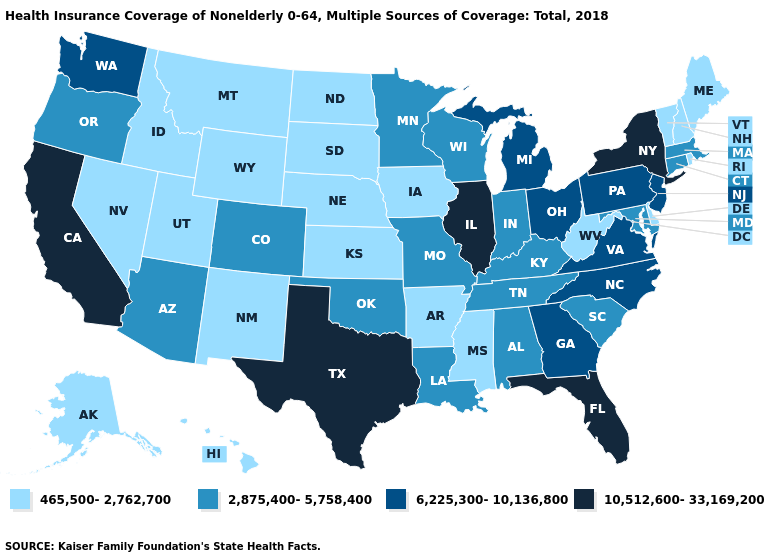What is the value of Oregon?
Concise answer only. 2,875,400-5,758,400. How many symbols are there in the legend?
Give a very brief answer. 4. Name the states that have a value in the range 465,500-2,762,700?
Concise answer only. Alaska, Arkansas, Delaware, Hawaii, Idaho, Iowa, Kansas, Maine, Mississippi, Montana, Nebraska, Nevada, New Hampshire, New Mexico, North Dakota, Rhode Island, South Dakota, Utah, Vermont, West Virginia, Wyoming. Which states have the lowest value in the USA?
Be succinct. Alaska, Arkansas, Delaware, Hawaii, Idaho, Iowa, Kansas, Maine, Mississippi, Montana, Nebraska, Nevada, New Hampshire, New Mexico, North Dakota, Rhode Island, South Dakota, Utah, Vermont, West Virginia, Wyoming. Which states hav the highest value in the Northeast?
Quick response, please. New York. Which states hav the highest value in the South?
Write a very short answer. Florida, Texas. What is the value of Kentucky?
Write a very short answer. 2,875,400-5,758,400. What is the value of Connecticut?
Give a very brief answer. 2,875,400-5,758,400. Name the states that have a value in the range 2,875,400-5,758,400?
Be succinct. Alabama, Arizona, Colorado, Connecticut, Indiana, Kentucky, Louisiana, Maryland, Massachusetts, Minnesota, Missouri, Oklahoma, Oregon, South Carolina, Tennessee, Wisconsin. Does the map have missing data?
Keep it brief. No. What is the lowest value in the USA?
Write a very short answer. 465,500-2,762,700. What is the highest value in the West ?
Concise answer only. 10,512,600-33,169,200. Which states hav the highest value in the South?
Keep it brief. Florida, Texas. Name the states that have a value in the range 10,512,600-33,169,200?
Be succinct. California, Florida, Illinois, New York, Texas. Name the states that have a value in the range 6,225,300-10,136,800?
Be succinct. Georgia, Michigan, New Jersey, North Carolina, Ohio, Pennsylvania, Virginia, Washington. 